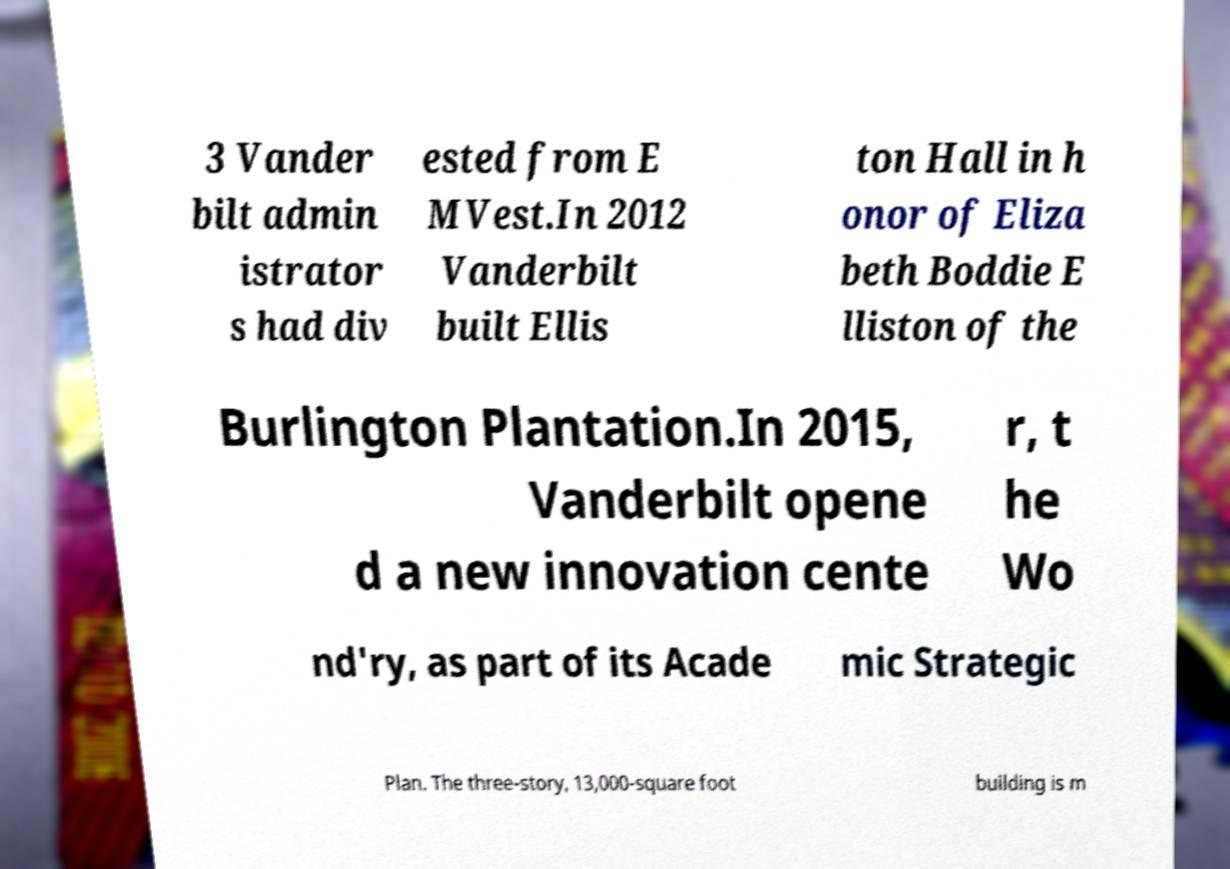For documentation purposes, I need the text within this image transcribed. Could you provide that? 3 Vander bilt admin istrator s had div ested from E MVest.In 2012 Vanderbilt built Ellis ton Hall in h onor of Eliza beth Boddie E lliston of the Burlington Plantation.In 2015, Vanderbilt opene d a new innovation cente r, t he Wo nd'ry, as part of its Acade mic Strategic Plan. The three-story, 13,000-square foot building is m 